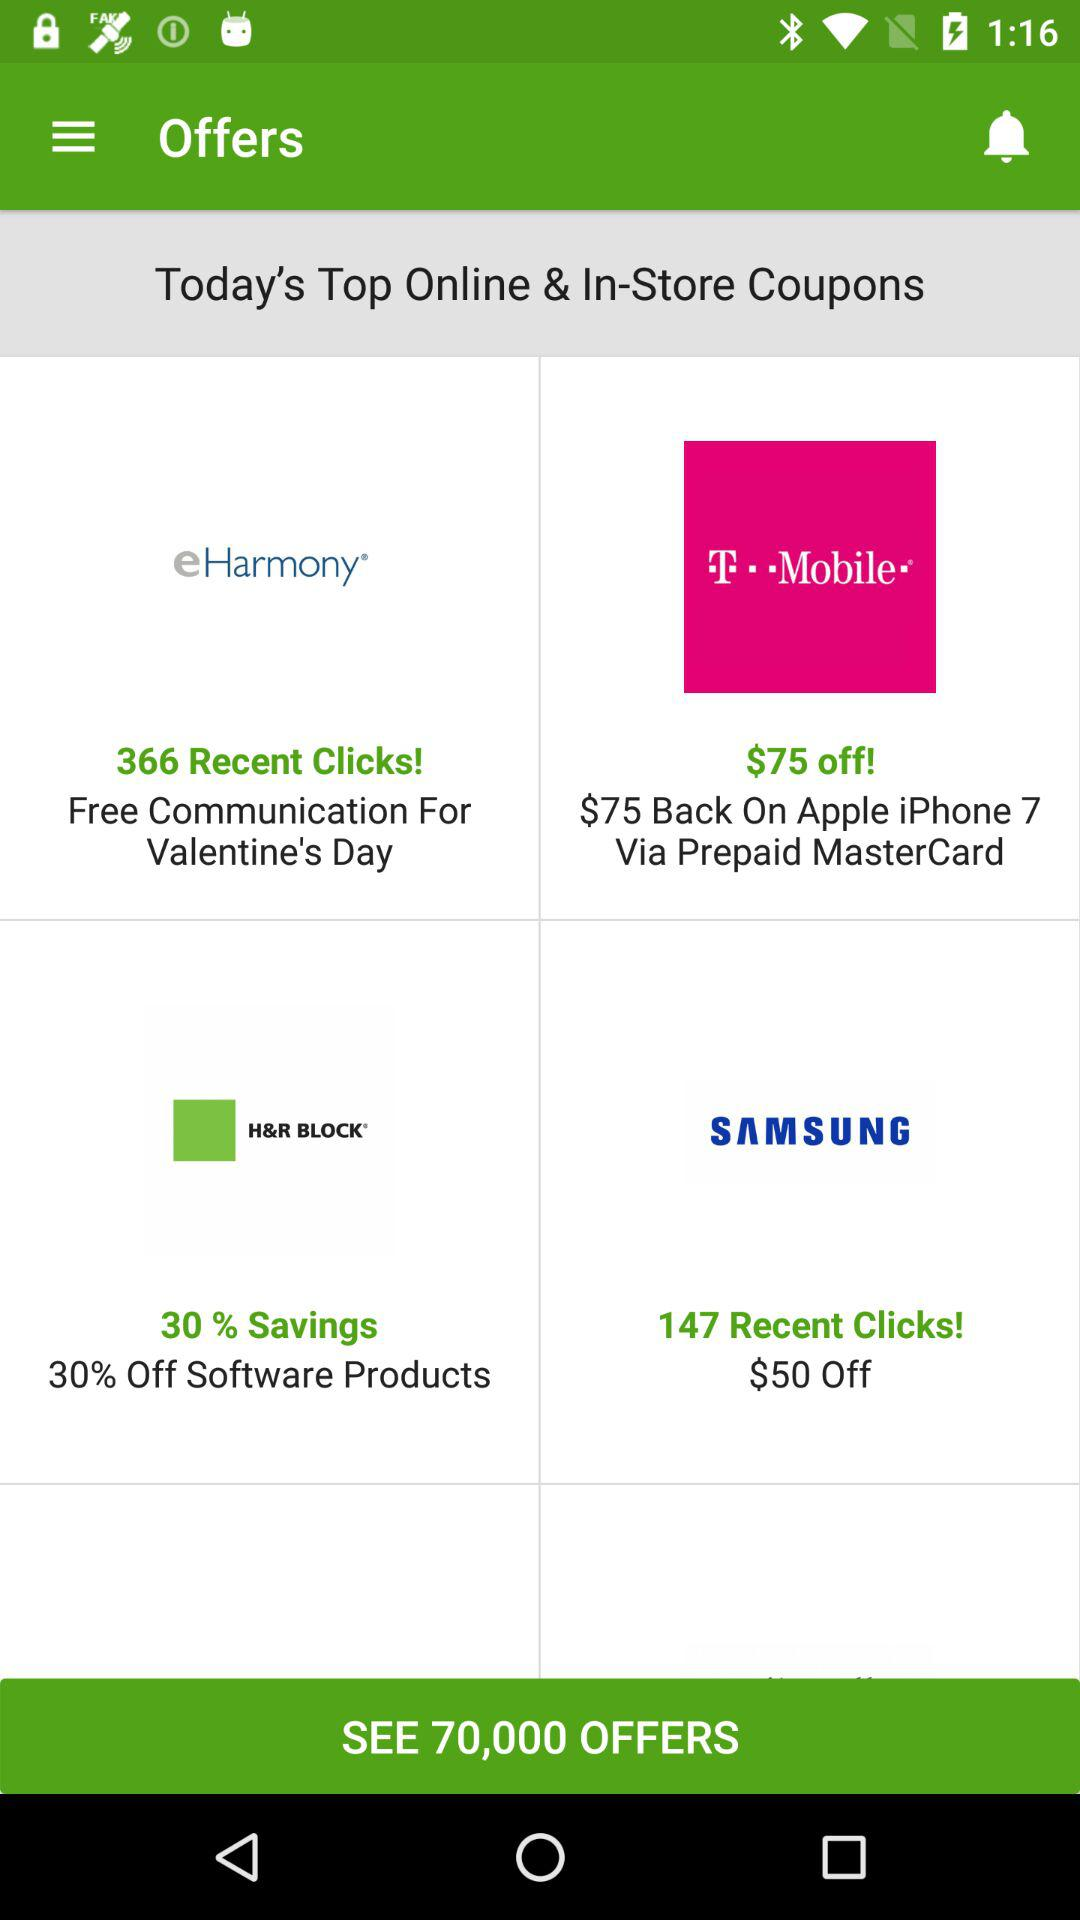How much money is back on Apple iPhone 7 products via Prepaid Mastercard? On Apple iPhone 7 products via Prepaid Mastercard, $75 is back. 